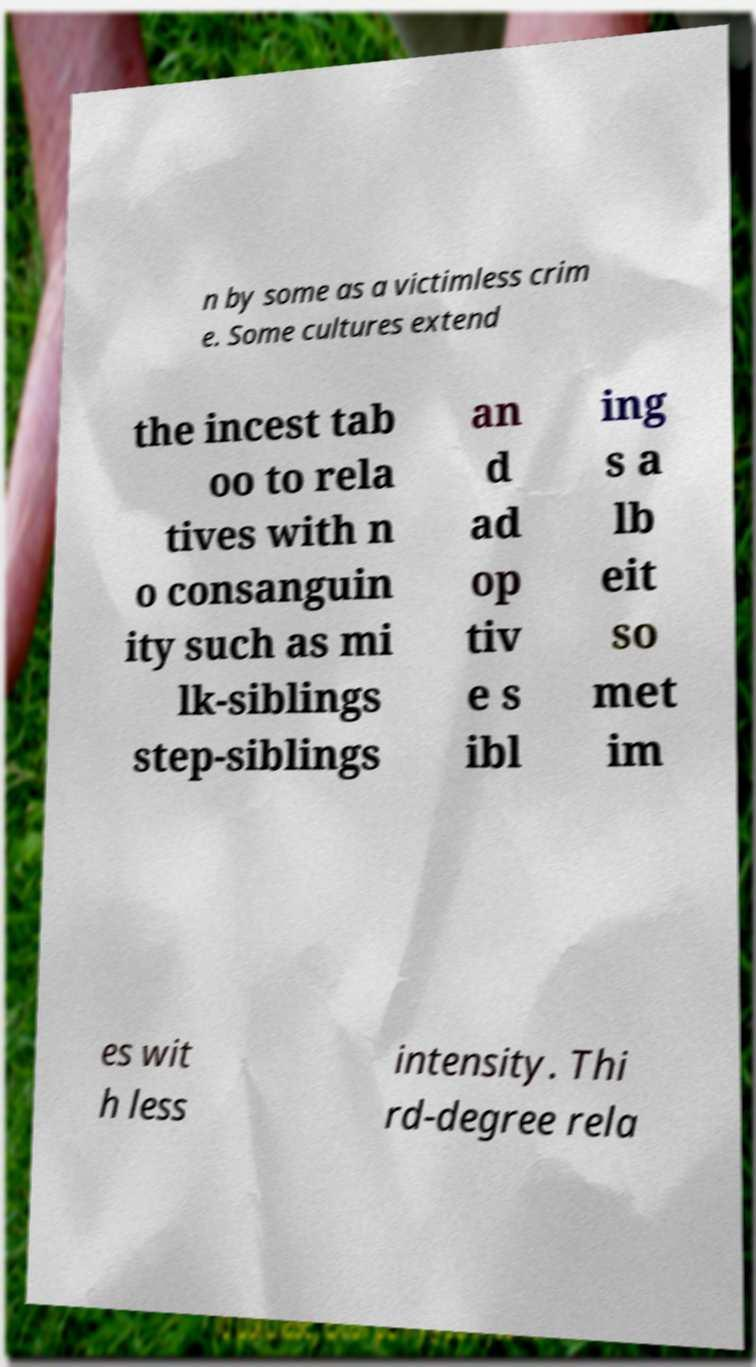Can you read and provide the text displayed in the image?This photo seems to have some interesting text. Can you extract and type it out for me? n by some as a victimless crim e. Some cultures extend the incest tab oo to rela tives with n o consanguin ity such as mi lk-siblings step-siblings an d ad op tiv e s ibl ing s a lb eit so met im es wit h less intensity. Thi rd-degree rela 